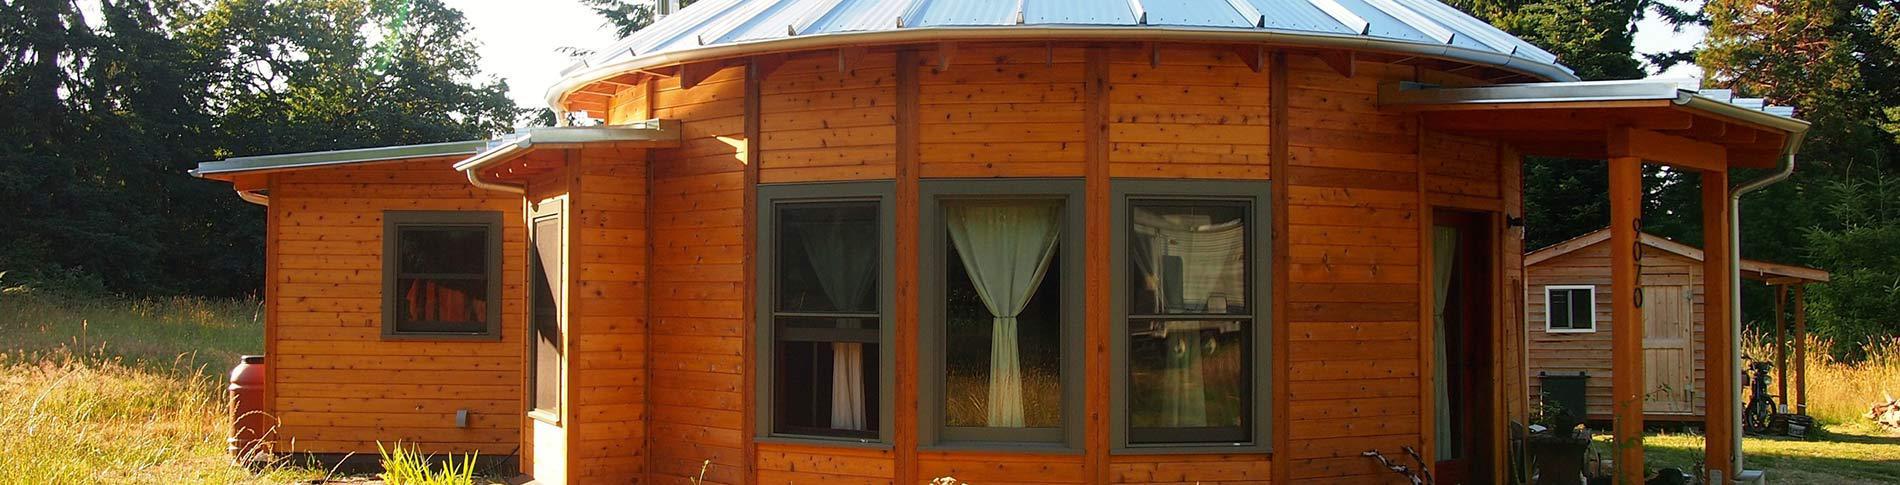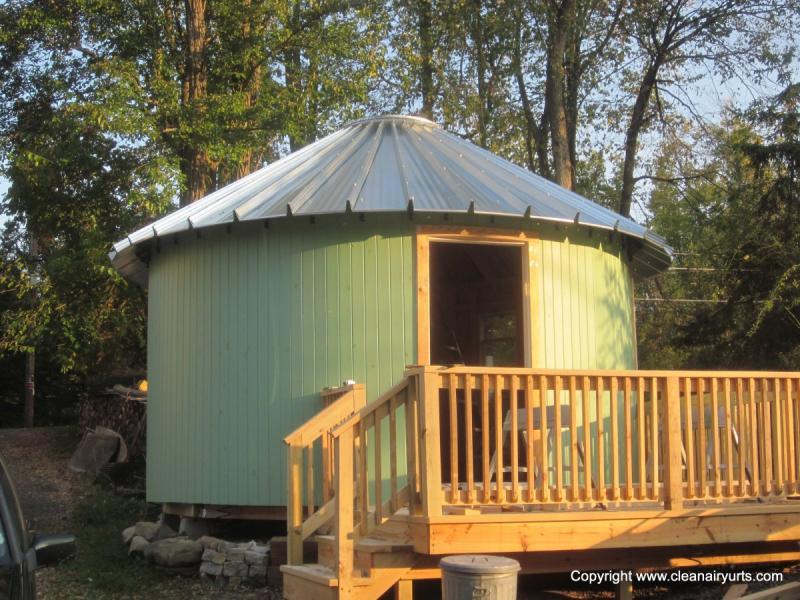The first image is the image on the left, the second image is the image on the right. Evaluate the accuracy of this statement regarding the images: "One image shows a cylindrical olive-green building with one door.". Is it true? Answer yes or no. Yes. 